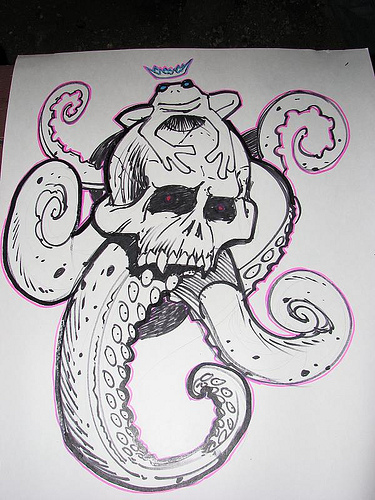<image>
Can you confirm if the frog is on the skull? Yes. Looking at the image, I can see the frog is positioned on top of the skull, with the skull providing support. Where is the octopus in relation to the frog? Is it in front of the frog? No. The octopus is not in front of the frog. The spatial positioning shows a different relationship between these objects. 